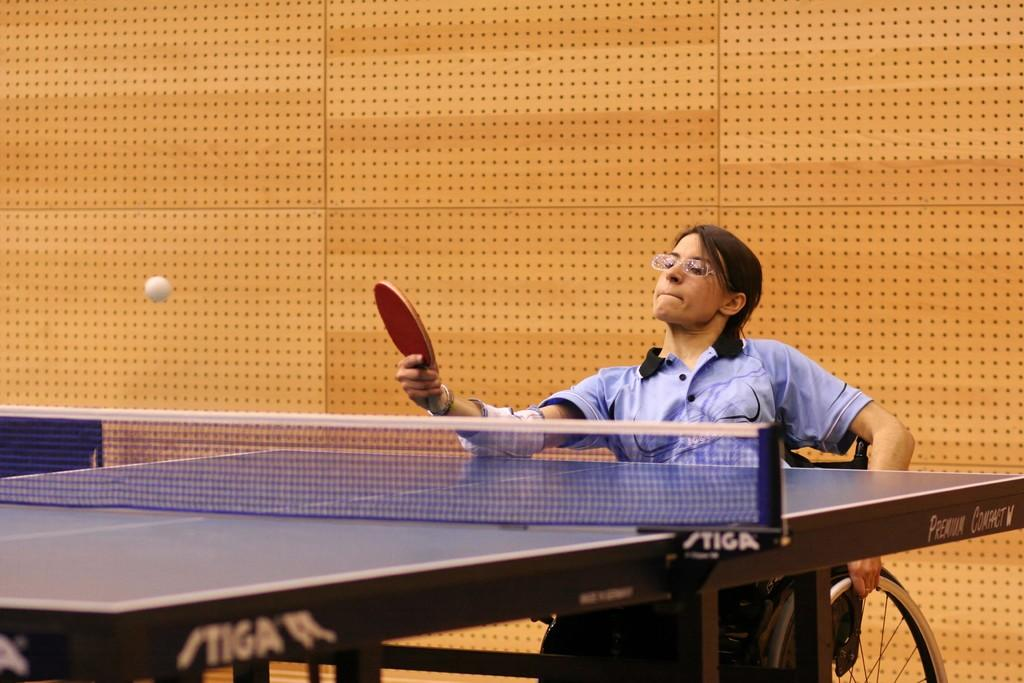Who is the main subject in the image? There is a woman in the image. What is the woman doing in the image? The woman is playing table tennis. What is the woman sitting on in the image? The woman is sitting on a wheelchair. What is used to separate the two sides of the table tennis game? There is a net in the image. What is used to hit the ball back and forth during the game? There is a ball in the image. What type of wall can be seen in the background of the image? There is no wall visible in the background of the image. What account does the woman have with the table tennis equipment supplier? There is no information about the woman's account with the table tennis equipment supplier in the image. 